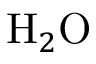Convert formula to latex. <formula><loc_0><loc_0><loc_500><loc_500>H _ { 2 } O</formula> 